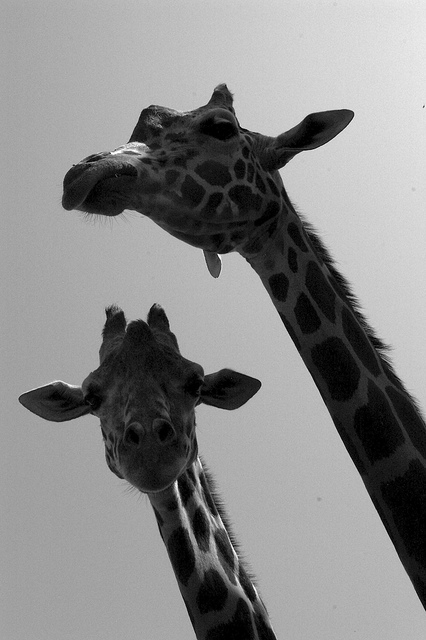<image>Why is the giraffe head between the fence? It is unknown why the giraffe's head is between the fence. It might not be in the image. Why is the giraffe head between the fence? It is ambiguous why the giraffe head is between the fence. It could be because they are tall, or to see something. 